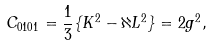Convert formula to latex. <formula><loc_0><loc_0><loc_500><loc_500>C _ { 0 1 0 1 } = \frac { 1 } { 3 } \{ K ^ { 2 } - \aleph L ^ { 2 } \} = 2 g ^ { 2 } ,</formula> 